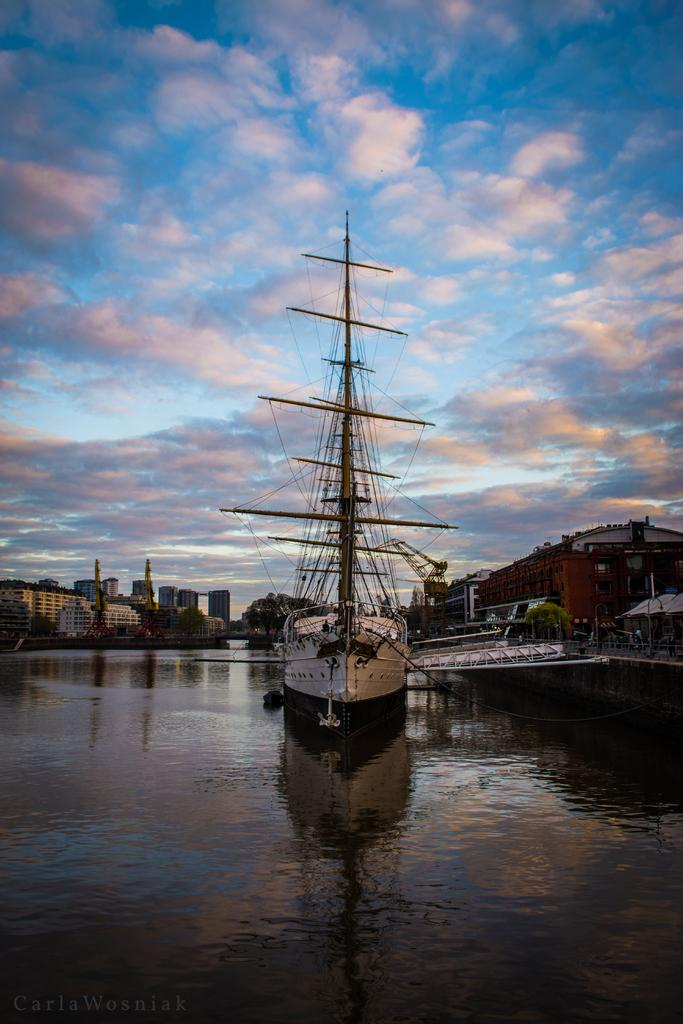What is at the bottom of the image? There is water at the bottom of the image. What is located in the middle of the image? There is a ship in the middle of the image. What can be seen in the background of the image? There are buildings and trees in the background of the image. What is visible at the top of the image? The sky is visible at the top of the image. What type of wall can be seen in the image? There is no wall present in the image. What is the ship's position in the competition? There is no competition present in the image, so it is not possible to determine the ship's position. 